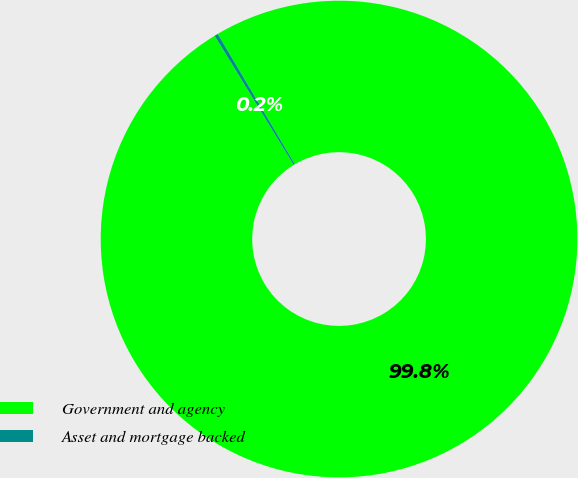<chart> <loc_0><loc_0><loc_500><loc_500><pie_chart><fcel>Government and agency<fcel>Asset and mortgage backed<nl><fcel>99.76%<fcel>0.24%<nl></chart> 